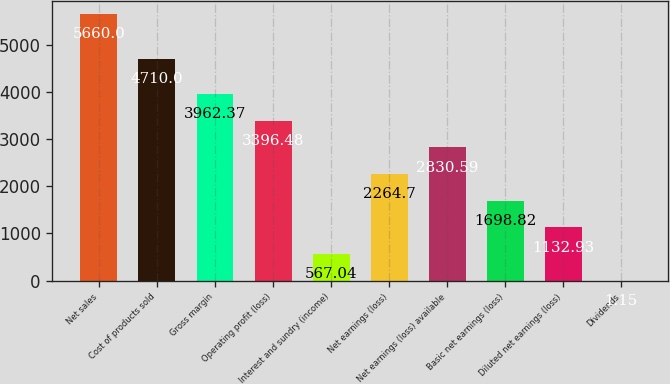<chart> <loc_0><loc_0><loc_500><loc_500><bar_chart><fcel>Net sales<fcel>Cost of products sold<fcel>Gross margin<fcel>Operating profit (loss)<fcel>Interest and sundry (income)<fcel>Net earnings (loss)<fcel>Net earnings (loss) available<fcel>Basic net earnings (loss)<fcel>Diluted net earnings (loss)<fcel>Dividends<nl><fcel>5660<fcel>4710<fcel>3962.37<fcel>3396.48<fcel>567.04<fcel>2264.7<fcel>2830.59<fcel>1698.82<fcel>1132.93<fcel>1.15<nl></chart> 